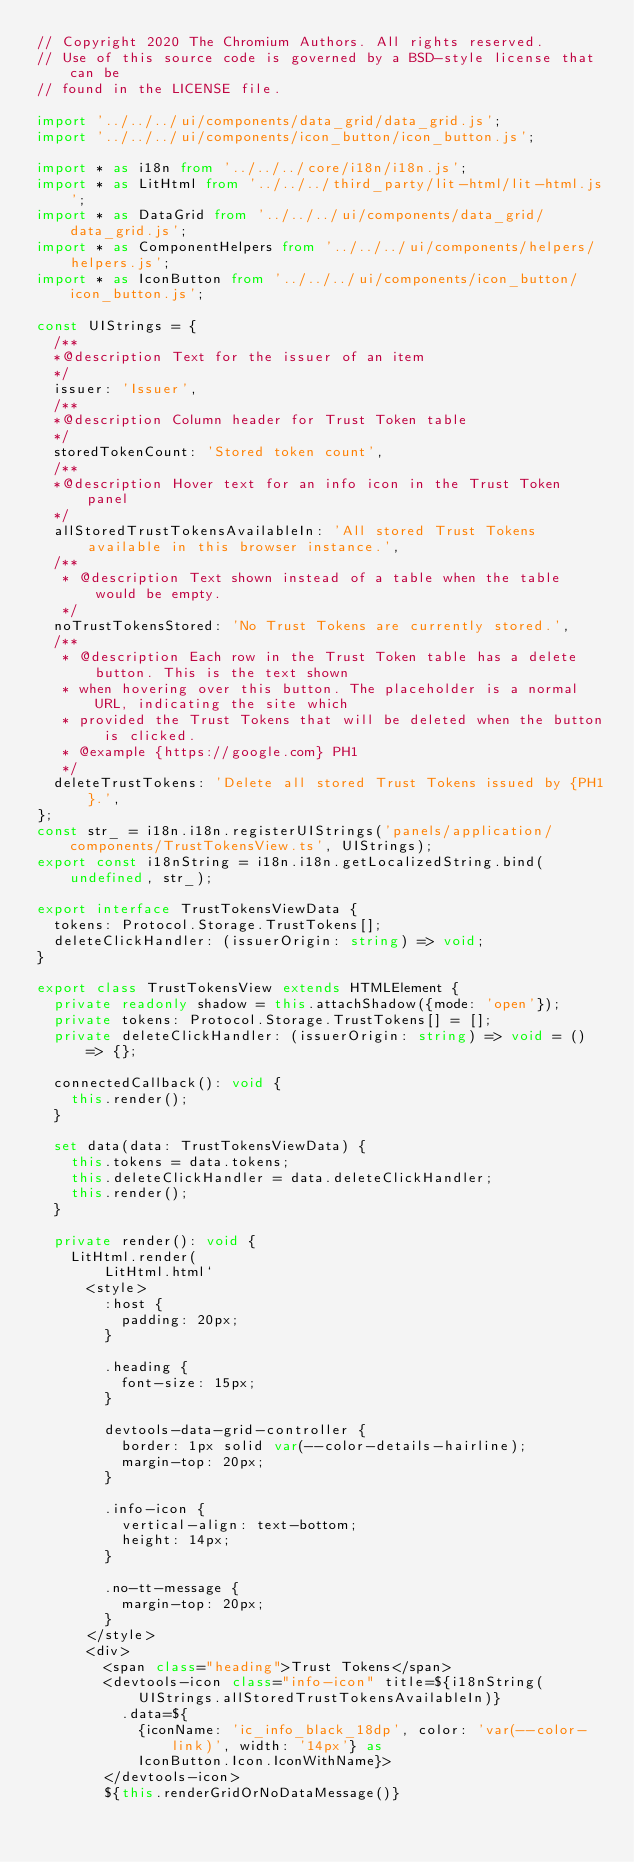<code> <loc_0><loc_0><loc_500><loc_500><_TypeScript_>// Copyright 2020 The Chromium Authors. All rights reserved.
// Use of this source code is governed by a BSD-style license that can be
// found in the LICENSE file.

import '../../../ui/components/data_grid/data_grid.js';
import '../../../ui/components/icon_button/icon_button.js';

import * as i18n from '../../../core/i18n/i18n.js';
import * as LitHtml from '../../../third_party/lit-html/lit-html.js';
import * as DataGrid from '../../../ui/components/data_grid/data_grid.js';
import * as ComponentHelpers from '../../../ui/components/helpers/helpers.js';
import * as IconButton from '../../../ui/components/icon_button/icon_button.js';

const UIStrings = {
  /**
  *@description Text for the issuer of an item
  */
  issuer: 'Issuer',
  /**
  *@description Column header for Trust Token table
  */
  storedTokenCount: 'Stored token count',
  /**
  *@description Hover text for an info icon in the Trust Token panel
  */
  allStoredTrustTokensAvailableIn: 'All stored Trust Tokens available in this browser instance.',
  /**
   * @description Text shown instead of a table when the table would be empty.
   */
  noTrustTokensStored: 'No Trust Tokens are currently stored.',
  /**
   * @description Each row in the Trust Token table has a delete button. This is the text shown
   * when hovering over this button. The placeholder is a normal URL, indicating the site which
   * provided the Trust Tokens that will be deleted when the button is clicked.
   * @example {https://google.com} PH1
   */
  deleteTrustTokens: 'Delete all stored Trust Tokens issued by {PH1}.',
};
const str_ = i18n.i18n.registerUIStrings('panels/application/components/TrustTokensView.ts', UIStrings);
export const i18nString = i18n.i18n.getLocalizedString.bind(undefined, str_);

export interface TrustTokensViewData {
  tokens: Protocol.Storage.TrustTokens[];
  deleteClickHandler: (issuerOrigin: string) => void;
}

export class TrustTokensView extends HTMLElement {
  private readonly shadow = this.attachShadow({mode: 'open'});
  private tokens: Protocol.Storage.TrustTokens[] = [];
  private deleteClickHandler: (issuerOrigin: string) => void = () => {};

  connectedCallback(): void {
    this.render();
  }

  set data(data: TrustTokensViewData) {
    this.tokens = data.tokens;
    this.deleteClickHandler = data.deleteClickHandler;
    this.render();
  }

  private render(): void {
    LitHtml.render(
        LitHtml.html`
      <style>
        :host {
          padding: 20px;
        }

        .heading {
          font-size: 15px;
        }

        devtools-data-grid-controller {
          border: 1px solid var(--color-details-hairline);
          margin-top: 20px;
        }

        .info-icon {
          vertical-align: text-bottom;
          height: 14px;
        }

        .no-tt-message {
          margin-top: 20px;
        }
      </style>
      <div>
        <span class="heading">Trust Tokens</span>
        <devtools-icon class="info-icon" title=${i18nString(UIStrings.allStoredTrustTokensAvailableIn)}
          .data=${
            {iconName: 'ic_info_black_18dp', color: 'var(--color-link)', width: '14px'} as
            IconButton.Icon.IconWithName}>
        </devtools-icon>
        ${this.renderGridOrNoDataMessage()}</code> 